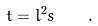<formula> <loc_0><loc_0><loc_500><loc_500>t = l ^ { 2 } s \quad .</formula> 